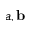Convert formula to latex. <formula><loc_0><loc_0><loc_500><loc_500>a , \mathbf b</formula> 